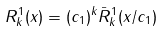Convert formula to latex. <formula><loc_0><loc_0><loc_500><loc_500>R ^ { 1 } _ { k } ( x ) = ( c _ { 1 } ) ^ { k } { \bar { R } } ^ { 1 } _ { k } ( x / c _ { 1 } )</formula> 